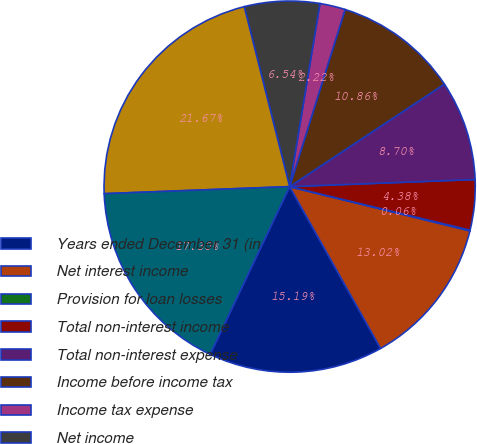Convert chart. <chart><loc_0><loc_0><loc_500><loc_500><pie_chart><fcel>Years ended December 31 (in<fcel>Net interest income<fcel>Provision for loan losses<fcel>Total non-interest income<fcel>Total non-interest expense<fcel>Income before income tax<fcel>Income tax expense<fcel>Net income<fcel>Average total assets<fcel>Average total liabilities<nl><fcel>15.19%<fcel>13.02%<fcel>0.06%<fcel>4.38%<fcel>8.7%<fcel>10.86%<fcel>2.22%<fcel>6.54%<fcel>21.67%<fcel>17.35%<nl></chart> 